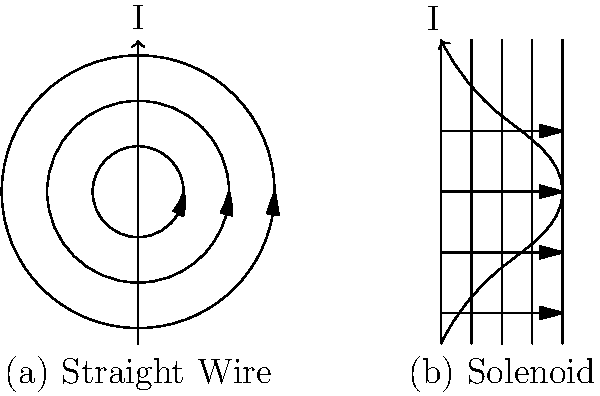Compare the magnetic field lines around a straight wire carrying current I and a solenoid with the same current I. Which configuration produces a more uniform magnetic field inside the coil, and why is this property significant in electrical engineering applications? 1. Straight wire:
   - Magnetic field lines form concentric circles around the wire.
   - Field strength decreases with distance from the wire ($ B \propto \frac{1}{r} $).
   - Field is non-uniform and extends indefinitely in space.

2. Solenoid:
   - Magnetic field lines are parallel and densely packed inside the coil.
   - Field is stronger and more uniform inside the solenoid.
   - Outside the solenoid, the field resembles that of a bar magnet.

3. Uniformity comparison:
   - The solenoid produces a more uniform magnetic field inside the coil.
   - This is due to the additive effect of multiple wire loops.

4. Significance in electrical engineering:
   - Uniform fields are crucial for many applications, such as:
     a) Electromagnets in motors and generators
     b) Magnetic resonance imaging (MRI) machines
     c) Particle accelerators
   - Uniform fields provide consistent force on charged particles or magnetic materials.
   - They allow for precise control and manipulation in various devices.

5. Historical context:
   - The discovery and understanding of these magnetic field properties in the 19th century led to significant technological advancements.
   - Inventors like Nikola Tesla utilized these principles in developing AC motors and transformers.
Answer: Solenoid; uniform fields enable precise control in electromagnets, motors, and medical devices. 